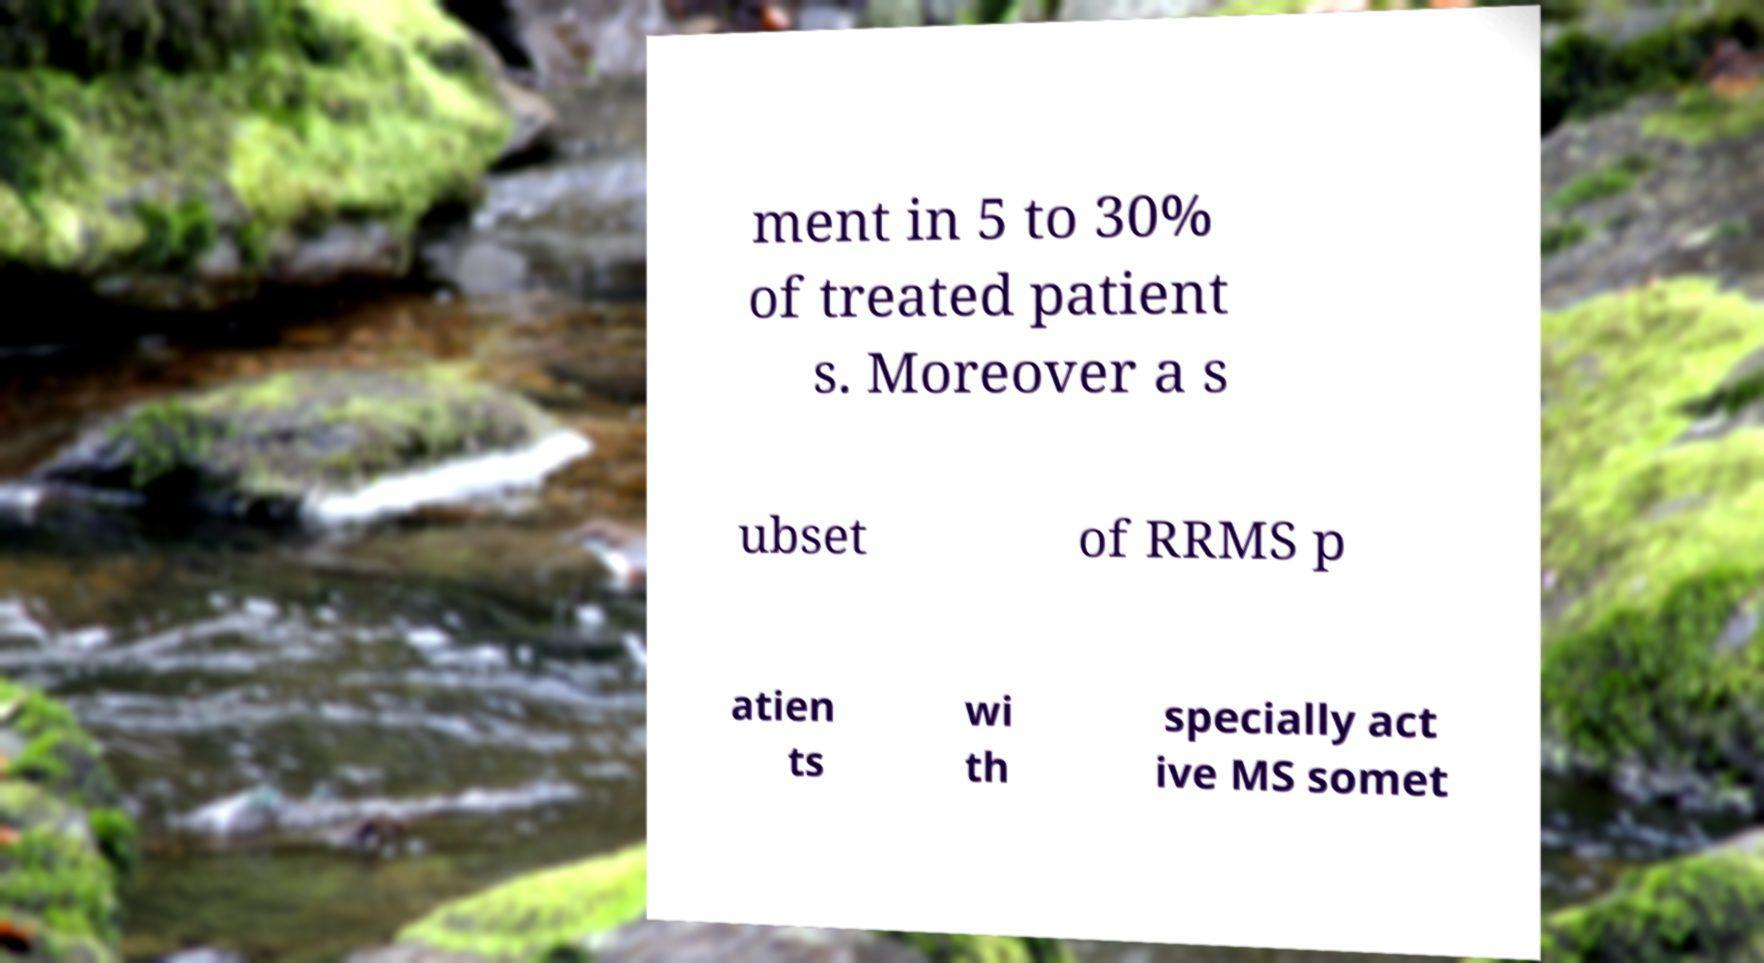Can you read and provide the text displayed in the image?This photo seems to have some interesting text. Can you extract and type it out for me? ment in 5 to 30% of treated patient s. Moreover a s ubset of RRMS p atien ts wi th specially act ive MS somet 